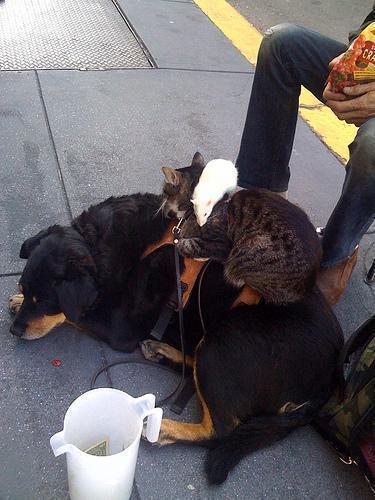Which mammal will disturb more species with it's movement?
Select the accurate response from the four choices given to answer the question.
Options: Cat, rat, man, dog. Dog. 